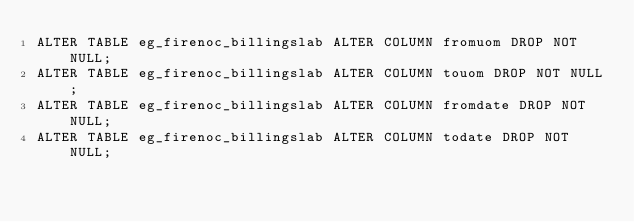<code> <loc_0><loc_0><loc_500><loc_500><_SQL_>ALTER TABLE eg_firenoc_billingslab ALTER COLUMN fromuom DROP NOT NULL;
ALTER TABLE eg_firenoc_billingslab ALTER COLUMN touom DROP NOT NULL;
ALTER TABLE eg_firenoc_billingslab ALTER COLUMN fromdate DROP NOT NULL;
ALTER TABLE eg_firenoc_billingslab ALTER COLUMN todate DROP NOT NULL;
</code> 